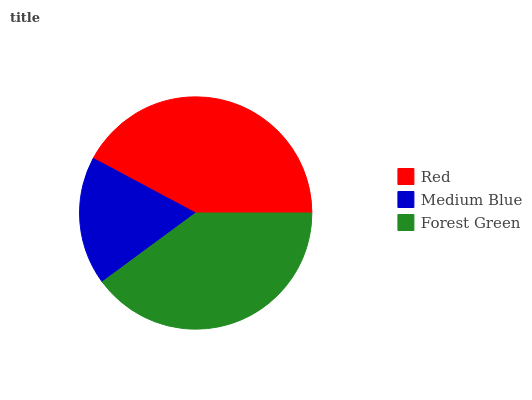Is Medium Blue the minimum?
Answer yes or no. Yes. Is Red the maximum?
Answer yes or no. Yes. Is Forest Green the minimum?
Answer yes or no. No. Is Forest Green the maximum?
Answer yes or no. No. Is Forest Green greater than Medium Blue?
Answer yes or no. Yes. Is Medium Blue less than Forest Green?
Answer yes or no. Yes. Is Medium Blue greater than Forest Green?
Answer yes or no. No. Is Forest Green less than Medium Blue?
Answer yes or no. No. Is Forest Green the high median?
Answer yes or no. Yes. Is Forest Green the low median?
Answer yes or no. Yes. Is Medium Blue the high median?
Answer yes or no. No. Is Red the low median?
Answer yes or no. No. 